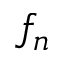<formula> <loc_0><loc_0><loc_500><loc_500>f _ { n }</formula> 